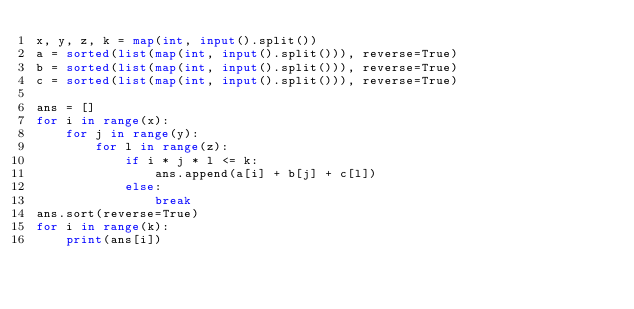<code> <loc_0><loc_0><loc_500><loc_500><_Python_>x, y, z, k = map(int, input().split())
a = sorted(list(map(int, input().split())), reverse=True)
b = sorted(list(map(int, input().split())), reverse=True)
c = sorted(list(map(int, input().split())), reverse=True)

ans = []
for i in range(x):
    for j in range(y):
        for l in range(z):
            if i * j * l <= k:
                ans.append(a[i] + b[j] + c[l])
            else:
                break
ans.sort(reverse=True)
for i in range(k):
    print(ans[i])</code> 